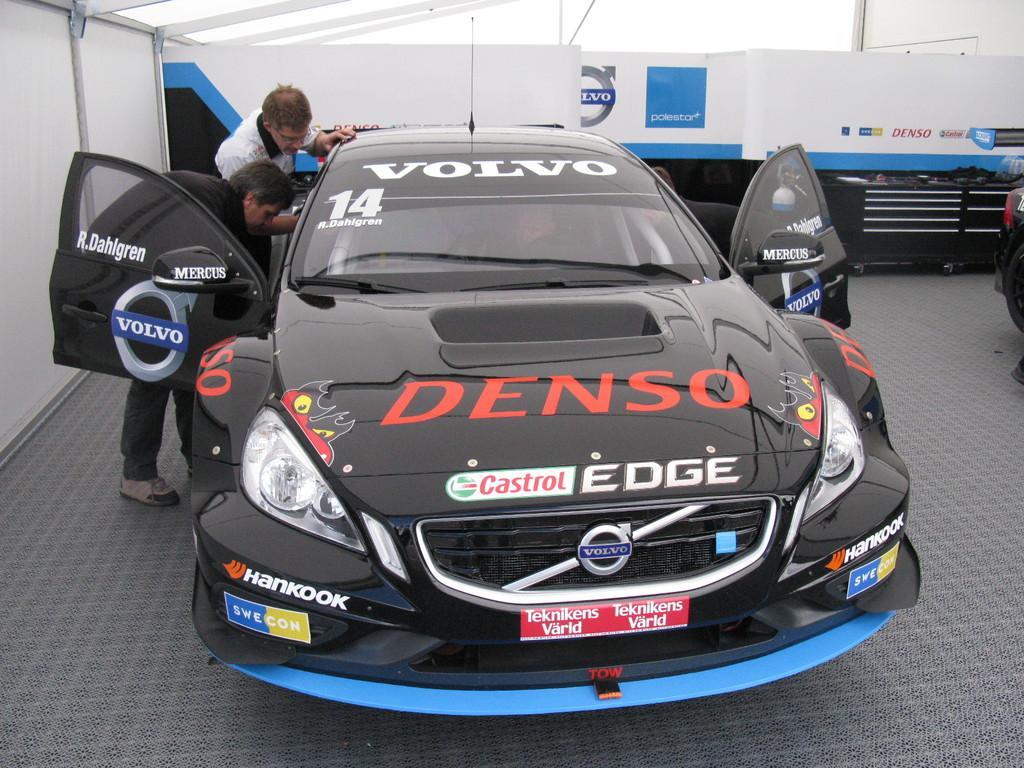Please provide a concise description of this image. In this picture we can see a car on the ground, here we can see people and in the background we can see a wall, advertisement board and some objects. 